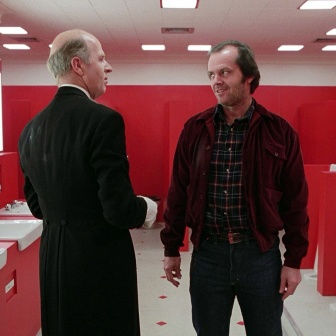Imagine this image is part of a mystery novel. What might the backstory be for these characters? In a mystery novel, this image could depict a clandestine meeting between two key characters. The man in the black suit might be a high-ranking detective or an enigmatic informant with crucial information about a hidden conspiracy. The man in the red jacket could be an investigative journalist or a rogue cop who is pushing the boundaries to uncover the truth. The red bathroom, therefore, becomes their secret meeting spot, where crucial and dangerous information is exchanged away from prying eyes. Their conversation might revolve around the next lead or an impending threat that they must tackle together, against all odds. 